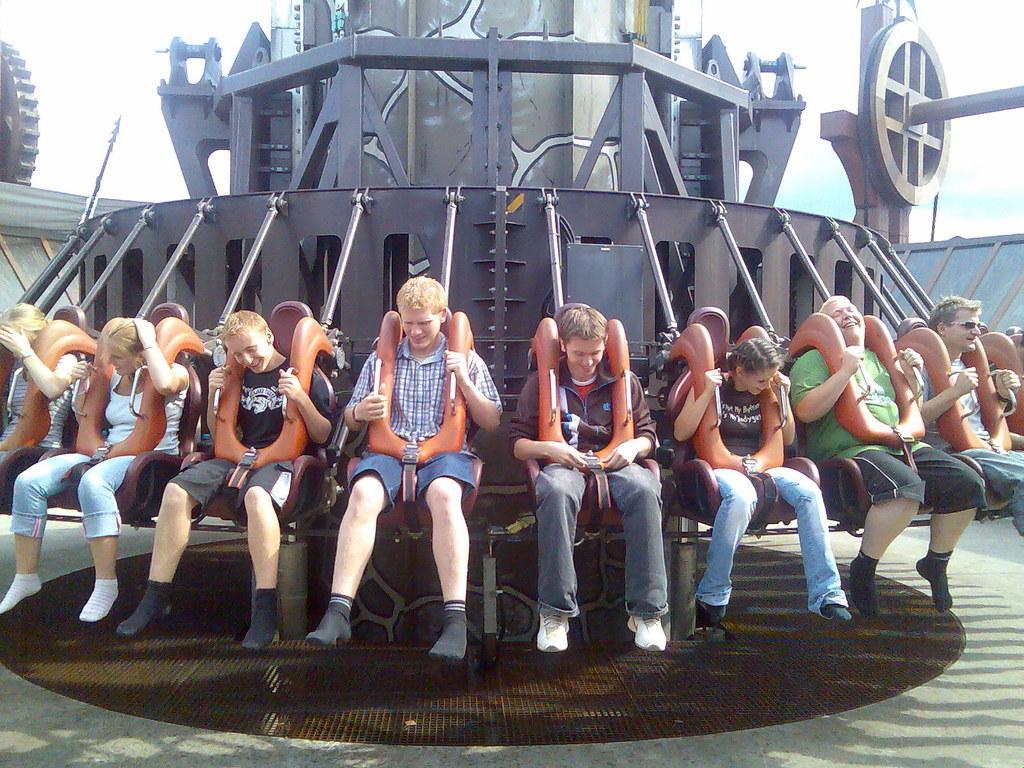In one or two sentences, can you explain what this image depicts? In this image I can see people sitting on a ride. There is sky at the top. 